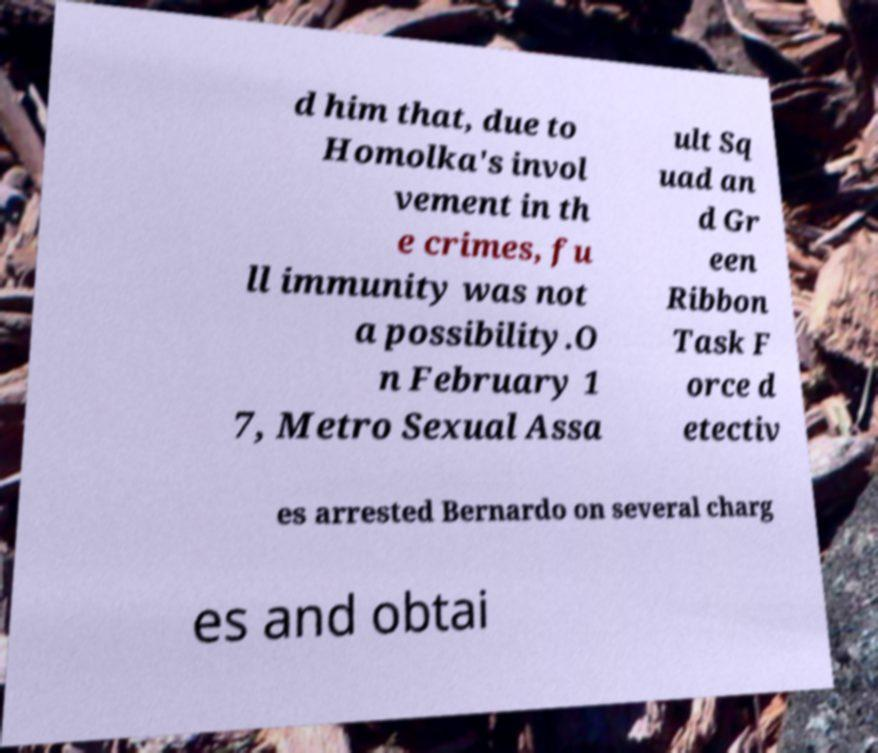Can you read and provide the text displayed in the image?This photo seems to have some interesting text. Can you extract and type it out for me? d him that, due to Homolka's invol vement in th e crimes, fu ll immunity was not a possibility.O n February 1 7, Metro Sexual Assa ult Sq uad an d Gr een Ribbon Task F orce d etectiv es arrested Bernardo on several charg es and obtai 